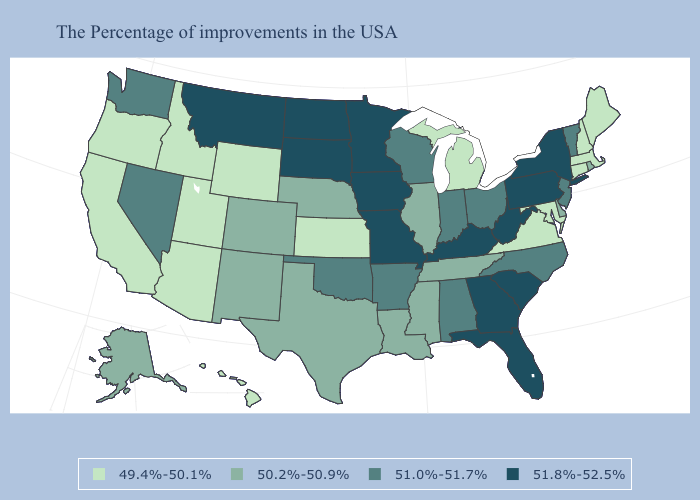Which states have the lowest value in the South?
Be succinct. Maryland, Virginia. Name the states that have a value in the range 51.0%-51.7%?
Concise answer only. Vermont, New Jersey, North Carolina, Ohio, Indiana, Alabama, Wisconsin, Arkansas, Oklahoma, Nevada, Washington. Does the first symbol in the legend represent the smallest category?
Short answer required. Yes. Is the legend a continuous bar?
Give a very brief answer. No. Does Indiana have the lowest value in the USA?
Give a very brief answer. No. Is the legend a continuous bar?
Short answer required. No. Does the map have missing data?
Be succinct. No. What is the value of Louisiana?
Quick response, please. 50.2%-50.9%. What is the value of North Dakota?
Short answer required. 51.8%-52.5%. Does Rhode Island have a higher value than Missouri?
Be succinct. No. Which states have the highest value in the USA?
Be succinct. New York, Pennsylvania, South Carolina, West Virginia, Florida, Georgia, Kentucky, Missouri, Minnesota, Iowa, South Dakota, North Dakota, Montana. Does Arizona have the lowest value in the West?
Quick response, please. Yes. What is the lowest value in the USA?
Keep it brief. 49.4%-50.1%. What is the value of Alaska?
Answer briefly. 50.2%-50.9%. 